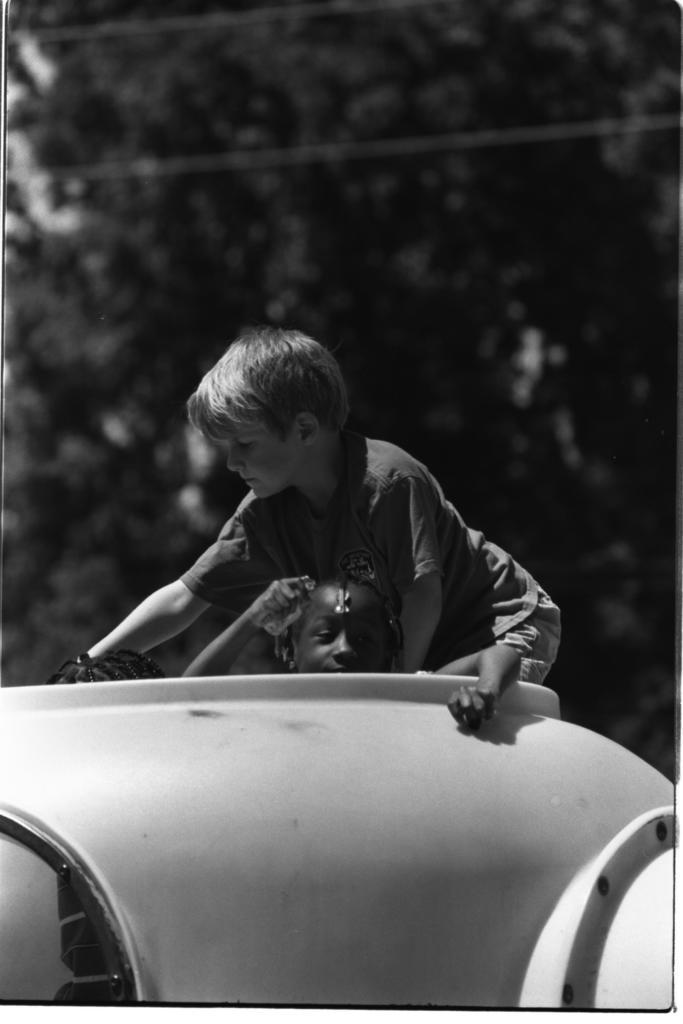What is the color scheme of the image? The image is black and white. What can be seen inside an object in the image? There is a kid inside an object in the image. What is the boy doing in relation to the object in the image? There is a boy on the object in the image. How would you describe the background of the image? The background of the image is blurred. What type of produce is being sold at the low prices in the image? There is no produce or mention of low prices in the image; it is a black and white image featuring a kid inside an object and a boy on the object with a blurred background. 